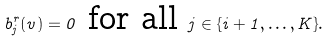<formula> <loc_0><loc_0><loc_500><loc_500>b ^ { r } _ { j } ( v ) = 0 \text { for all } j \in \{ i + 1 , \dots , K \} .</formula> 